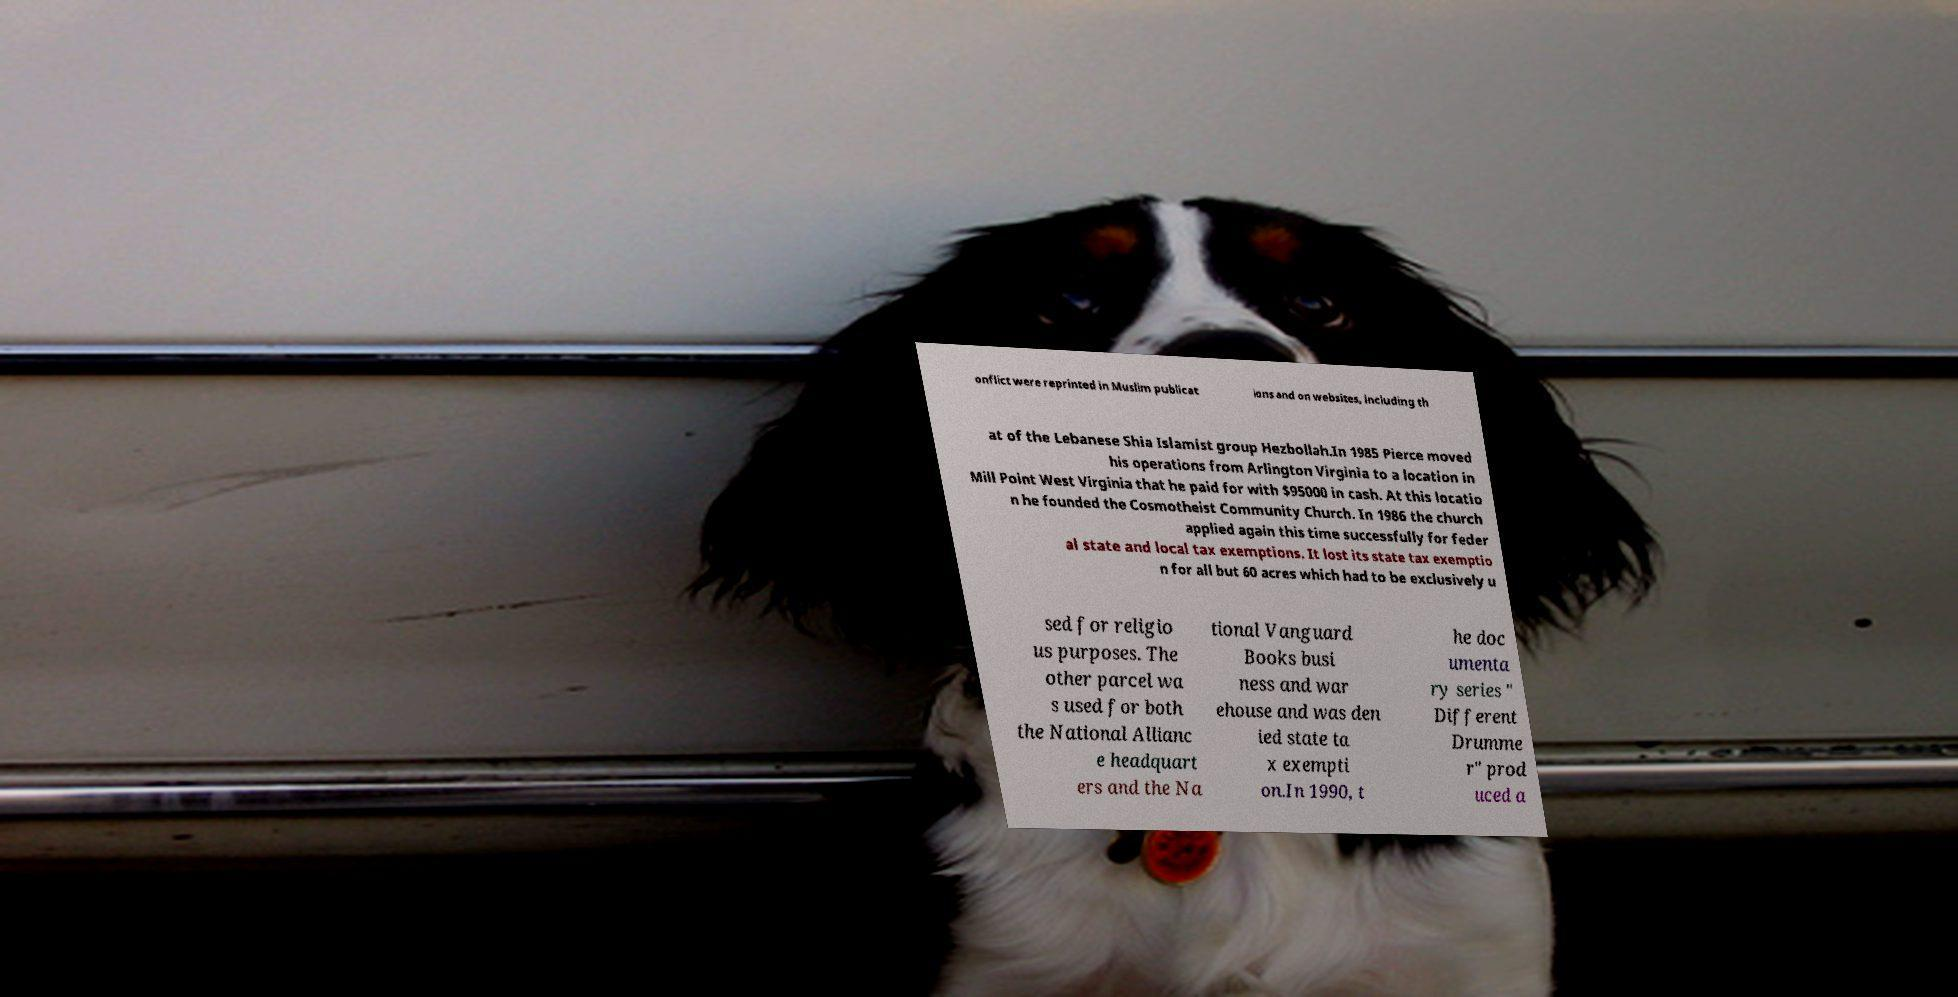What messages or text are displayed in this image? I need them in a readable, typed format. onflict were reprinted in Muslim publicat ions and on websites, including th at of the Lebanese Shia Islamist group Hezbollah.In 1985 Pierce moved his operations from Arlington Virginia to a location in Mill Point West Virginia that he paid for with $95000 in cash. At this locatio n he founded the Cosmotheist Community Church. In 1986 the church applied again this time successfully for feder al state and local tax exemptions. It lost its state tax exemptio n for all but 60 acres which had to be exclusively u sed for religio us purposes. The other parcel wa s used for both the National Allianc e headquart ers and the Na tional Vanguard Books busi ness and war ehouse and was den ied state ta x exempti on.In 1990, t he doc umenta ry series " Different Drumme r" prod uced a 